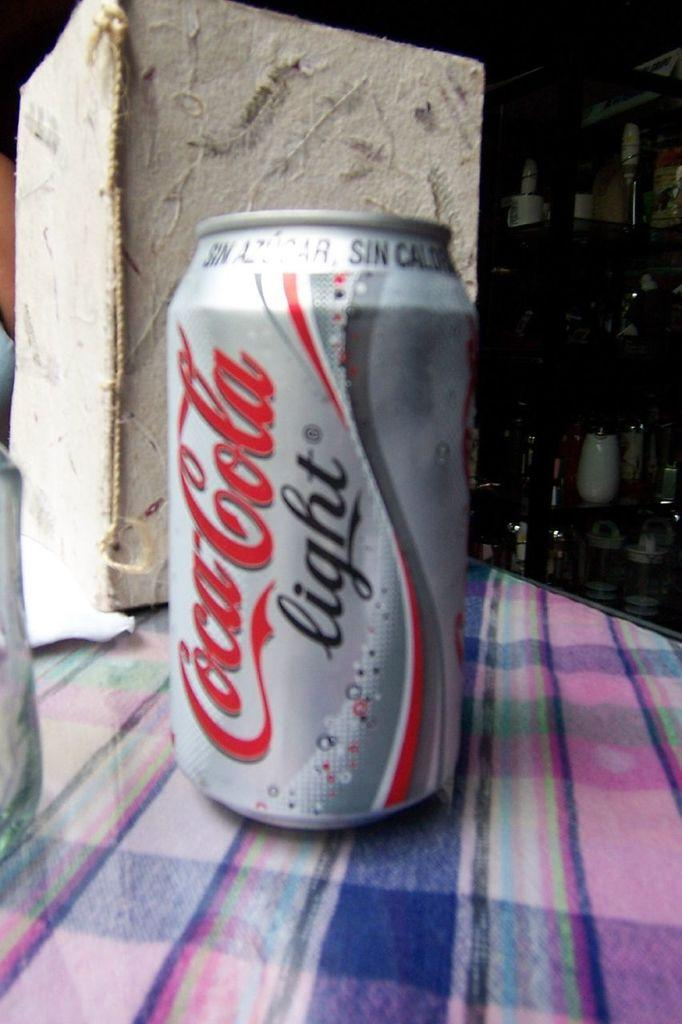<image>
Offer a succinct explanation of the picture presented. A can of Coca Cola light sits on a plaid tablecloth. 